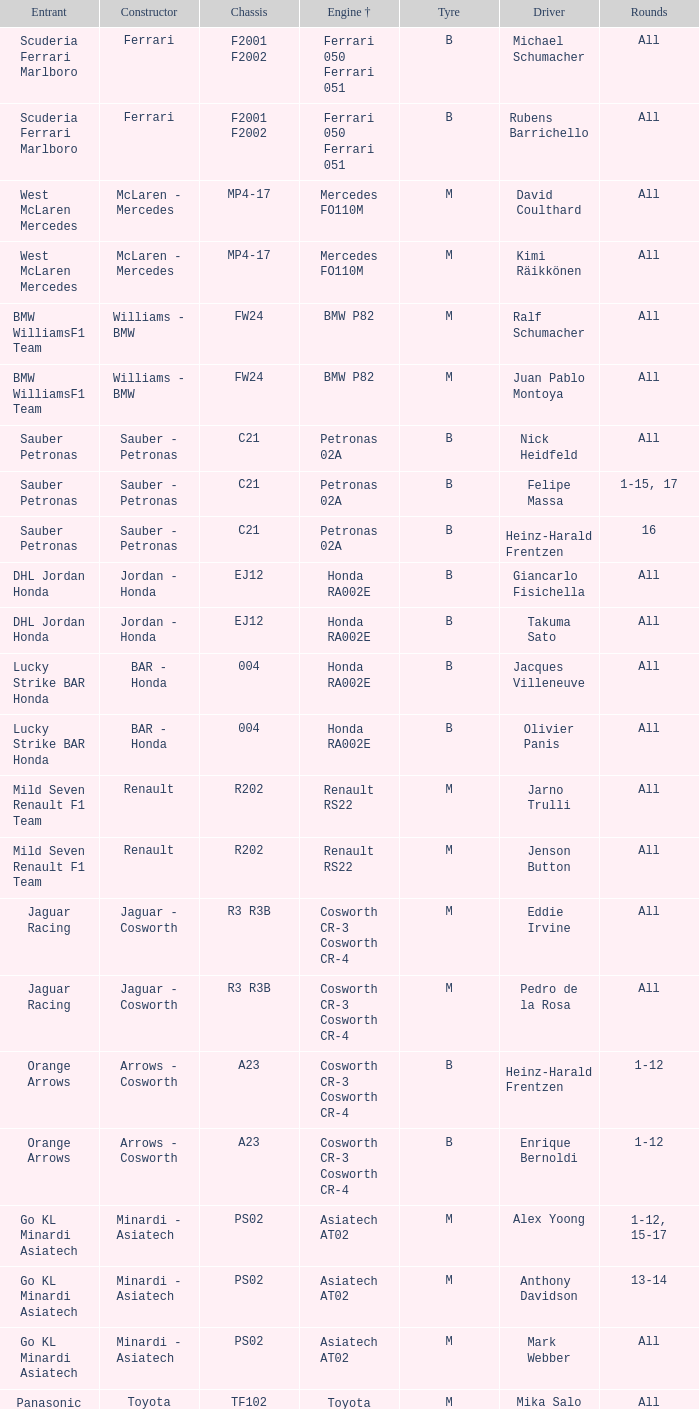Who is the operator when the motor is mercedes fo110m? David Coulthard, Kimi Räikkönen. 